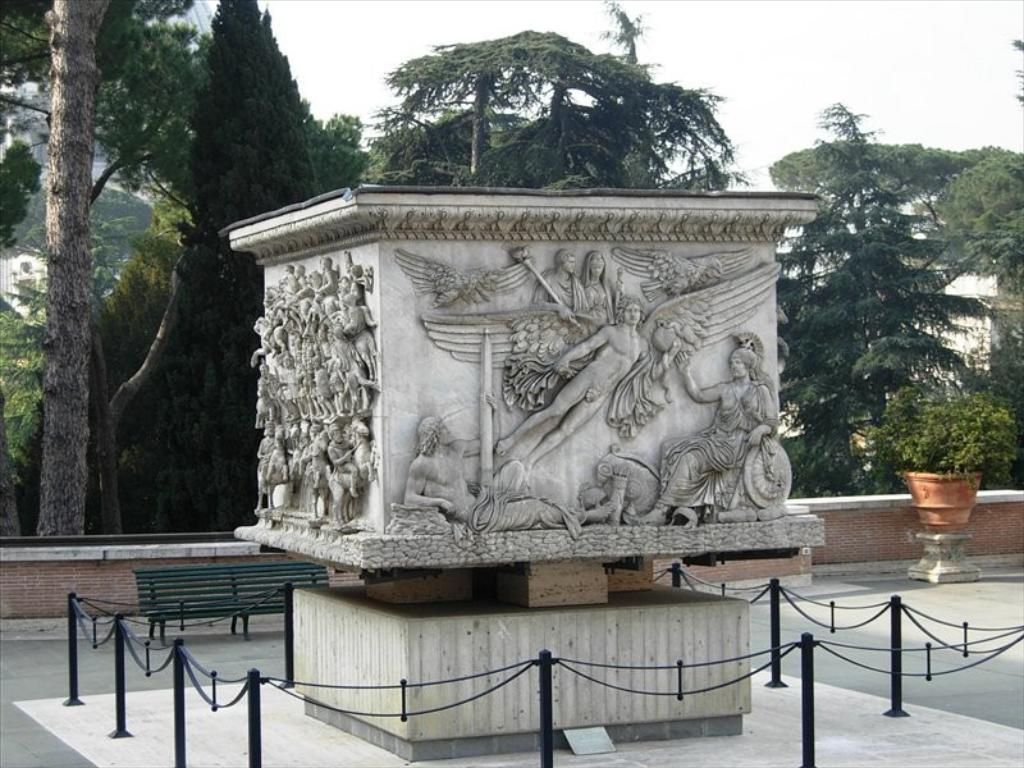What is the object in the image that has sculptures on it? The facts do not specify the object with sculptures, but we know there are sculptures on an object in the image. What type of barrier can be seen in the image? There is a fence in the image. What type of seating is present in the image? There is a bench in the image. What type of plant is in a container on the ground in the image? There is a potted plant on the ground in the image. What can be seen in the background of the image? Trees, a wall, and the sky are visible in the background of the image. What type of breakfast is being served on the bench in the image? There is no mention of breakfast or any food in the image. What type of drain is visible in the image? There is no drain present in the image. 